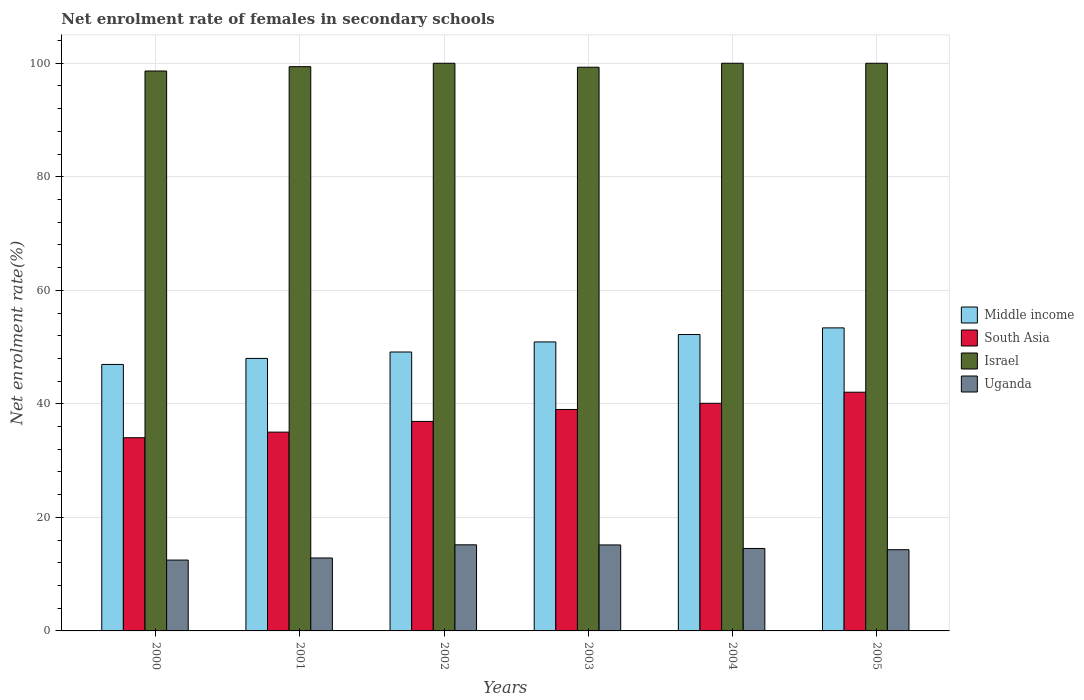Are the number of bars per tick equal to the number of legend labels?
Keep it short and to the point. Yes. Are the number of bars on each tick of the X-axis equal?
Provide a succinct answer. Yes. What is the label of the 1st group of bars from the left?
Provide a short and direct response. 2000. In how many cases, is the number of bars for a given year not equal to the number of legend labels?
Keep it short and to the point. 0. What is the net enrolment rate of females in secondary schools in Uganda in 2002?
Give a very brief answer. 15.17. Across all years, what is the maximum net enrolment rate of females in secondary schools in Uganda?
Offer a very short reply. 15.17. Across all years, what is the minimum net enrolment rate of females in secondary schools in Uganda?
Your response must be concise. 12.48. In which year was the net enrolment rate of females in secondary schools in Middle income maximum?
Your response must be concise. 2005. What is the total net enrolment rate of females in secondary schools in Uganda in the graph?
Your answer should be compact. 84.48. What is the difference between the net enrolment rate of females in secondary schools in Israel in 2002 and that in 2003?
Provide a succinct answer. 0.7. What is the difference between the net enrolment rate of females in secondary schools in Uganda in 2005 and the net enrolment rate of females in secondary schools in South Asia in 2004?
Ensure brevity in your answer.  -25.79. What is the average net enrolment rate of females in secondary schools in Uganda per year?
Provide a succinct answer. 14.08. In the year 2005, what is the difference between the net enrolment rate of females in secondary schools in Uganda and net enrolment rate of females in secondary schools in South Asia?
Ensure brevity in your answer.  -27.74. In how many years, is the net enrolment rate of females in secondary schools in Middle income greater than 16 %?
Make the answer very short. 6. What is the ratio of the net enrolment rate of females in secondary schools in Israel in 2001 to that in 2004?
Offer a very short reply. 0.99. What is the difference between the highest and the second highest net enrolment rate of females in secondary schools in Middle income?
Make the answer very short. 1.17. What is the difference between the highest and the lowest net enrolment rate of females in secondary schools in Uganda?
Give a very brief answer. 2.69. In how many years, is the net enrolment rate of females in secondary schools in Uganda greater than the average net enrolment rate of females in secondary schools in Uganda taken over all years?
Give a very brief answer. 4. Is the sum of the net enrolment rate of females in secondary schools in Uganda in 2000 and 2001 greater than the maximum net enrolment rate of females in secondary schools in Middle income across all years?
Ensure brevity in your answer.  No. Is it the case that in every year, the sum of the net enrolment rate of females in secondary schools in Uganda and net enrolment rate of females in secondary schools in South Asia is greater than the sum of net enrolment rate of females in secondary schools in Middle income and net enrolment rate of females in secondary schools in Israel?
Ensure brevity in your answer.  No. What does the 1st bar from the left in 2004 represents?
Provide a succinct answer. Middle income. How many bars are there?
Offer a terse response. 24. Are the values on the major ticks of Y-axis written in scientific E-notation?
Your answer should be very brief. No. Does the graph contain grids?
Keep it short and to the point. Yes. How many legend labels are there?
Ensure brevity in your answer.  4. What is the title of the graph?
Provide a succinct answer. Net enrolment rate of females in secondary schools. Does "Mali" appear as one of the legend labels in the graph?
Keep it short and to the point. No. What is the label or title of the X-axis?
Make the answer very short. Years. What is the label or title of the Y-axis?
Your response must be concise. Net enrolment rate(%). What is the Net enrolment rate(%) in Middle income in 2000?
Offer a very short reply. 46.94. What is the Net enrolment rate(%) of South Asia in 2000?
Give a very brief answer. 34.03. What is the Net enrolment rate(%) of Israel in 2000?
Provide a succinct answer. 98.64. What is the Net enrolment rate(%) in Uganda in 2000?
Provide a succinct answer. 12.48. What is the Net enrolment rate(%) of Middle income in 2001?
Ensure brevity in your answer.  48. What is the Net enrolment rate(%) in South Asia in 2001?
Give a very brief answer. 35.02. What is the Net enrolment rate(%) of Israel in 2001?
Ensure brevity in your answer.  99.4. What is the Net enrolment rate(%) in Uganda in 2001?
Your response must be concise. 12.85. What is the Net enrolment rate(%) in Middle income in 2002?
Ensure brevity in your answer.  49.13. What is the Net enrolment rate(%) in South Asia in 2002?
Offer a terse response. 36.91. What is the Net enrolment rate(%) of Israel in 2002?
Your answer should be very brief. 100. What is the Net enrolment rate(%) of Uganda in 2002?
Give a very brief answer. 15.17. What is the Net enrolment rate(%) of Middle income in 2003?
Your answer should be very brief. 50.91. What is the Net enrolment rate(%) in South Asia in 2003?
Ensure brevity in your answer.  39.01. What is the Net enrolment rate(%) of Israel in 2003?
Offer a terse response. 99.3. What is the Net enrolment rate(%) in Uganda in 2003?
Provide a succinct answer. 15.15. What is the Net enrolment rate(%) in Middle income in 2004?
Give a very brief answer. 52.21. What is the Net enrolment rate(%) in South Asia in 2004?
Provide a short and direct response. 40.1. What is the Net enrolment rate(%) in Israel in 2004?
Your answer should be very brief. 100. What is the Net enrolment rate(%) in Uganda in 2004?
Offer a terse response. 14.53. What is the Net enrolment rate(%) in Middle income in 2005?
Ensure brevity in your answer.  53.38. What is the Net enrolment rate(%) of South Asia in 2005?
Provide a succinct answer. 42.05. What is the Net enrolment rate(%) of Israel in 2005?
Provide a short and direct response. 100. What is the Net enrolment rate(%) of Uganda in 2005?
Your answer should be very brief. 14.31. Across all years, what is the maximum Net enrolment rate(%) in Middle income?
Your answer should be very brief. 53.38. Across all years, what is the maximum Net enrolment rate(%) in South Asia?
Your answer should be very brief. 42.05. Across all years, what is the maximum Net enrolment rate(%) of Uganda?
Your answer should be very brief. 15.17. Across all years, what is the minimum Net enrolment rate(%) in Middle income?
Keep it short and to the point. 46.94. Across all years, what is the minimum Net enrolment rate(%) in South Asia?
Make the answer very short. 34.03. Across all years, what is the minimum Net enrolment rate(%) of Israel?
Your answer should be very brief. 98.64. Across all years, what is the minimum Net enrolment rate(%) in Uganda?
Offer a terse response. 12.48. What is the total Net enrolment rate(%) of Middle income in the graph?
Provide a short and direct response. 300.59. What is the total Net enrolment rate(%) of South Asia in the graph?
Provide a short and direct response. 227.12. What is the total Net enrolment rate(%) in Israel in the graph?
Give a very brief answer. 597.34. What is the total Net enrolment rate(%) of Uganda in the graph?
Your response must be concise. 84.48. What is the difference between the Net enrolment rate(%) of Middle income in 2000 and that in 2001?
Make the answer very short. -1.06. What is the difference between the Net enrolment rate(%) of South Asia in 2000 and that in 2001?
Provide a succinct answer. -0.99. What is the difference between the Net enrolment rate(%) in Israel in 2000 and that in 2001?
Your answer should be very brief. -0.76. What is the difference between the Net enrolment rate(%) in Uganda in 2000 and that in 2001?
Provide a short and direct response. -0.37. What is the difference between the Net enrolment rate(%) of Middle income in 2000 and that in 2002?
Offer a terse response. -2.19. What is the difference between the Net enrolment rate(%) in South Asia in 2000 and that in 2002?
Make the answer very short. -2.88. What is the difference between the Net enrolment rate(%) of Israel in 2000 and that in 2002?
Your response must be concise. -1.36. What is the difference between the Net enrolment rate(%) of Uganda in 2000 and that in 2002?
Give a very brief answer. -2.69. What is the difference between the Net enrolment rate(%) in Middle income in 2000 and that in 2003?
Offer a very short reply. -3.96. What is the difference between the Net enrolment rate(%) in South Asia in 2000 and that in 2003?
Ensure brevity in your answer.  -4.98. What is the difference between the Net enrolment rate(%) in Israel in 2000 and that in 2003?
Make the answer very short. -0.66. What is the difference between the Net enrolment rate(%) in Uganda in 2000 and that in 2003?
Your answer should be very brief. -2.67. What is the difference between the Net enrolment rate(%) of Middle income in 2000 and that in 2004?
Give a very brief answer. -5.27. What is the difference between the Net enrolment rate(%) in South Asia in 2000 and that in 2004?
Your answer should be compact. -6.07. What is the difference between the Net enrolment rate(%) in Israel in 2000 and that in 2004?
Provide a short and direct response. -1.36. What is the difference between the Net enrolment rate(%) of Uganda in 2000 and that in 2004?
Give a very brief answer. -2.05. What is the difference between the Net enrolment rate(%) in Middle income in 2000 and that in 2005?
Keep it short and to the point. -6.44. What is the difference between the Net enrolment rate(%) of South Asia in 2000 and that in 2005?
Your answer should be very brief. -8.02. What is the difference between the Net enrolment rate(%) in Israel in 2000 and that in 2005?
Your response must be concise. -1.36. What is the difference between the Net enrolment rate(%) of Uganda in 2000 and that in 2005?
Provide a succinct answer. -1.83. What is the difference between the Net enrolment rate(%) of Middle income in 2001 and that in 2002?
Offer a very short reply. -1.13. What is the difference between the Net enrolment rate(%) of South Asia in 2001 and that in 2002?
Your answer should be very brief. -1.89. What is the difference between the Net enrolment rate(%) in Israel in 2001 and that in 2002?
Keep it short and to the point. -0.6. What is the difference between the Net enrolment rate(%) of Uganda in 2001 and that in 2002?
Offer a very short reply. -2.32. What is the difference between the Net enrolment rate(%) of Middle income in 2001 and that in 2003?
Ensure brevity in your answer.  -2.9. What is the difference between the Net enrolment rate(%) in South Asia in 2001 and that in 2003?
Your answer should be compact. -3.99. What is the difference between the Net enrolment rate(%) in Israel in 2001 and that in 2003?
Provide a succinct answer. 0.1. What is the difference between the Net enrolment rate(%) in Uganda in 2001 and that in 2003?
Offer a terse response. -2.3. What is the difference between the Net enrolment rate(%) of Middle income in 2001 and that in 2004?
Provide a short and direct response. -4.21. What is the difference between the Net enrolment rate(%) in South Asia in 2001 and that in 2004?
Offer a terse response. -5.08. What is the difference between the Net enrolment rate(%) of Israel in 2001 and that in 2004?
Give a very brief answer. -0.6. What is the difference between the Net enrolment rate(%) of Uganda in 2001 and that in 2004?
Provide a short and direct response. -1.68. What is the difference between the Net enrolment rate(%) of Middle income in 2001 and that in 2005?
Your response must be concise. -5.38. What is the difference between the Net enrolment rate(%) of South Asia in 2001 and that in 2005?
Provide a succinct answer. -7.03. What is the difference between the Net enrolment rate(%) in Israel in 2001 and that in 2005?
Make the answer very short. -0.6. What is the difference between the Net enrolment rate(%) of Uganda in 2001 and that in 2005?
Ensure brevity in your answer.  -1.46. What is the difference between the Net enrolment rate(%) in Middle income in 2002 and that in 2003?
Provide a short and direct response. -1.77. What is the difference between the Net enrolment rate(%) in South Asia in 2002 and that in 2003?
Provide a short and direct response. -2.1. What is the difference between the Net enrolment rate(%) in Israel in 2002 and that in 2003?
Your answer should be very brief. 0.7. What is the difference between the Net enrolment rate(%) in Uganda in 2002 and that in 2003?
Offer a very short reply. 0.02. What is the difference between the Net enrolment rate(%) of Middle income in 2002 and that in 2004?
Keep it short and to the point. -3.08. What is the difference between the Net enrolment rate(%) of South Asia in 2002 and that in 2004?
Give a very brief answer. -3.19. What is the difference between the Net enrolment rate(%) in Israel in 2002 and that in 2004?
Provide a succinct answer. 0. What is the difference between the Net enrolment rate(%) of Uganda in 2002 and that in 2004?
Make the answer very short. 0.64. What is the difference between the Net enrolment rate(%) in Middle income in 2002 and that in 2005?
Provide a succinct answer. -4.25. What is the difference between the Net enrolment rate(%) of South Asia in 2002 and that in 2005?
Offer a terse response. -5.14. What is the difference between the Net enrolment rate(%) in Uganda in 2002 and that in 2005?
Ensure brevity in your answer.  0.86. What is the difference between the Net enrolment rate(%) of Middle income in 2003 and that in 2004?
Offer a terse response. -1.3. What is the difference between the Net enrolment rate(%) in South Asia in 2003 and that in 2004?
Make the answer very short. -1.09. What is the difference between the Net enrolment rate(%) in Israel in 2003 and that in 2004?
Keep it short and to the point. -0.7. What is the difference between the Net enrolment rate(%) of Uganda in 2003 and that in 2004?
Provide a short and direct response. 0.62. What is the difference between the Net enrolment rate(%) of Middle income in 2003 and that in 2005?
Offer a very short reply. -2.48. What is the difference between the Net enrolment rate(%) in South Asia in 2003 and that in 2005?
Ensure brevity in your answer.  -3.04. What is the difference between the Net enrolment rate(%) of Israel in 2003 and that in 2005?
Provide a succinct answer. -0.7. What is the difference between the Net enrolment rate(%) in Uganda in 2003 and that in 2005?
Your answer should be very brief. 0.84. What is the difference between the Net enrolment rate(%) of Middle income in 2004 and that in 2005?
Make the answer very short. -1.17. What is the difference between the Net enrolment rate(%) in South Asia in 2004 and that in 2005?
Ensure brevity in your answer.  -1.95. What is the difference between the Net enrolment rate(%) of Israel in 2004 and that in 2005?
Give a very brief answer. 0. What is the difference between the Net enrolment rate(%) of Uganda in 2004 and that in 2005?
Your response must be concise. 0.22. What is the difference between the Net enrolment rate(%) in Middle income in 2000 and the Net enrolment rate(%) in South Asia in 2001?
Ensure brevity in your answer.  11.92. What is the difference between the Net enrolment rate(%) in Middle income in 2000 and the Net enrolment rate(%) in Israel in 2001?
Your answer should be very brief. -52.45. What is the difference between the Net enrolment rate(%) of Middle income in 2000 and the Net enrolment rate(%) of Uganda in 2001?
Offer a terse response. 34.09. What is the difference between the Net enrolment rate(%) in South Asia in 2000 and the Net enrolment rate(%) in Israel in 2001?
Provide a succinct answer. -65.37. What is the difference between the Net enrolment rate(%) in South Asia in 2000 and the Net enrolment rate(%) in Uganda in 2001?
Offer a terse response. 21.18. What is the difference between the Net enrolment rate(%) in Israel in 2000 and the Net enrolment rate(%) in Uganda in 2001?
Make the answer very short. 85.79. What is the difference between the Net enrolment rate(%) in Middle income in 2000 and the Net enrolment rate(%) in South Asia in 2002?
Offer a terse response. 10.04. What is the difference between the Net enrolment rate(%) of Middle income in 2000 and the Net enrolment rate(%) of Israel in 2002?
Provide a short and direct response. -53.06. What is the difference between the Net enrolment rate(%) of Middle income in 2000 and the Net enrolment rate(%) of Uganda in 2002?
Ensure brevity in your answer.  31.78. What is the difference between the Net enrolment rate(%) of South Asia in 2000 and the Net enrolment rate(%) of Israel in 2002?
Your answer should be compact. -65.97. What is the difference between the Net enrolment rate(%) in South Asia in 2000 and the Net enrolment rate(%) in Uganda in 2002?
Your response must be concise. 18.87. What is the difference between the Net enrolment rate(%) of Israel in 2000 and the Net enrolment rate(%) of Uganda in 2002?
Your answer should be compact. 83.47. What is the difference between the Net enrolment rate(%) in Middle income in 2000 and the Net enrolment rate(%) in South Asia in 2003?
Provide a short and direct response. 7.93. What is the difference between the Net enrolment rate(%) of Middle income in 2000 and the Net enrolment rate(%) of Israel in 2003?
Ensure brevity in your answer.  -52.36. What is the difference between the Net enrolment rate(%) in Middle income in 2000 and the Net enrolment rate(%) in Uganda in 2003?
Your answer should be very brief. 31.8. What is the difference between the Net enrolment rate(%) in South Asia in 2000 and the Net enrolment rate(%) in Israel in 2003?
Give a very brief answer. -65.27. What is the difference between the Net enrolment rate(%) of South Asia in 2000 and the Net enrolment rate(%) of Uganda in 2003?
Offer a very short reply. 18.89. What is the difference between the Net enrolment rate(%) in Israel in 2000 and the Net enrolment rate(%) in Uganda in 2003?
Provide a succinct answer. 83.49. What is the difference between the Net enrolment rate(%) in Middle income in 2000 and the Net enrolment rate(%) in South Asia in 2004?
Ensure brevity in your answer.  6.85. What is the difference between the Net enrolment rate(%) of Middle income in 2000 and the Net enrolment rate(%) of Israel in 2004?
Offer a very short reply. -53.06. What is the difference between the Net enrolment rate(%) in Middle income in 2000 and the Net enrolment rate(%) in Uganda in 2004?
Your answer should be compact. 32.42. What is the difference between the Net enrolment rate(%) of South Asia in 2000 and the Net enrolment rate(%) of Israel in 2004?
Provide a short and direct response. -65.97. What is the difference between the Net enrolment rate(%) in South Asia in 2000 and the Net enrolment rate(%) in Uganda in 2004?
Your response must be concise. 19.51. What is the difference between the Net enrolment rate(%) in Israel in 2000 and the Net enrolment rate(%) in Uganda in 2004?
Give a very brief answer. 84.11. What is the difference between the Net enrolment rate(%) of Middle income in 2000 and the Net enrolment rate(%) of South Asia in 2005?
Ensure brevity in your answer.  4.89. What is the difference between the Net enrolment rate(%) of Middle income in 2000 and the Net enrolment rate(%) of Israel in 2005?
Offer a terse response. -53.06. What is the difference between the Net enrolment rate(%) of Middle income in 2000 and the Net enrolment rate(%) of Uganda in 2005?
Offer a very short reply. 32.64. What is the difference between the Net enrolment rate(%) in South Asia in 2000 and the Net enrolment rate(%) in Israel in 2005?
Provide a succinct answer. -65.97. What is the difference between the Net enrolment rate(%) in South Asia in 2000 and the Net enrolment rate(%) in Uganda in 2005?
Provide a short and direct response. 19.73. What is the difference between the Net enrolment rate(%) of Israel in 2000 and the Net enrolment rate(%) of Uganda in 2005?
Your response must be concise. 84.33. What is the difference between the Net enrolment rate(%) in Middle income in 2001 and the Net enrolment rate(%) in South Asia in 2002?
Keep it short and to the point. 11.1. What is the difference between the Net enrolment rate(%) of Middle income in 2001 and the Net enrolment rate(%) of Israel in 2002?
Keep it short and to the point. -52. What is the difference between the Net enrolment rate(%) in Middle income in 2001 and the Net enrolment rate(%) in Uganda in 2002?
Keep it short and to the point. 32.84. What is the difference between the Net enrolment rate(%) of South Asia in 2001 and the Net enrolment rate(%) of Israel in 2002?
Ensure brevity in your answer.  -64.98. What is the difference between the Net enrolment rate(%) in South Asia in 2001 and the Net enrolment rate(%) in Uganda in 2002?
Your response must be concise. 19.85. What is the difference between the Net enrolment rate(%) in Israel in 2001 and the Net enrolment rate(%) in Uganda in 2002?
Offer a very short reply. 84.23. What is the difference between the Net enrolment rate(%) in Middle income in 2001 and the Net enrolment rate(%) in South Asia in 2003?
Ensure brevity in your answer.  8.99. What is the difference between the Net enrolment rate(%) in Middle income in 2001 and the Net enrolment rate(%) in Israel in 2003?
Your answer should be very brief. -51.3. What is the difference between the Net enrolment rate(%) in Middle income in 2001 and the Net enrolment rate(%) in Uganda in 2003?
Your response must be concise. 32.86. What is the difference between the Net enrolment rate(%) in South Asia in 2001 and the Net enrolment rate(%) in Israel in 2003?
Provide a short and direct response. -64.28. What is the difference between the Net enrolment rate(%) in South Asia in 2001 and the Net enrolment rate(%) in Uganda in 2003?
Offer a very short reply. 19.87. What is the difference between the Net enrolment rate(%) in Israel in 2001 and the Net enrolment rate(%) in Uganda in 2003?
Make the answer very short. 84.25. What is the difference between the Net enrolment rate(%) of Middle income in 2001 and the Net enrolment rate(%) of South Asia in 2004?
Keep it short and to the point. 7.91. What is the difference between the Net enrolment rate(%) in Middle income in 2001 and the Net enrolment rate(%) in Israel in 2004?
Your response must be concise. -52. What is the difference between the Net enrolment rate(%) in Middle income in 2001 and the Net enrolment rate(%) in Uganda in 2004?
Offer a very short reply. 33.48. What is the difference between the Net enrolment rate(%) of South Asia in 2001 and the Net enrolment rate(%) of Israel in 2004?
Ensure brevity in your answer.  -64.98. What is the difference between the Net enrolment rate(%) in South Asia in 2001 and the Net enrolment rate(%) in Uganda in 2004?
Give a very brief answer. 20.49. What is the difference between the Net enrolment rate(%) in Israel in 2001 and the Net enrolment rate(%) in Uganda in 2004?
Your answer should be very brief. 84.87. What is the difference between the Net enrolment rate(%) of Middle income in 2001 and the Net enrolment rate(%) of South Asia in 2005?
Your answer should be compact. 5.95. What is the difference between the Net enrolment rate(%) of Middle income in 2001 and the Net enrolment rate(%) of Israel in 2005?
Keep it short and to the point. -52. What is the difference between the Net enrolment rate(%) of Middle income in 2001 and the Net enrolment rate(%) of Uganda in 2005?
Your answer should be compact. 33.7. What is the difference between the Net enrolment rate(%) of South Asia in 2001 and the Net enrolment rate(%) of Israel in 2005?
Your answer should be compact. -64.98. What is the difference between the Net enrolment rate(%) in South Asia in 2001 and the Net enrolment rate(%) in Uganda in 2005?
Your response must be concise. 20.71. What is the difference between the Net enrolment rate(%) in Israel in 2001 and the Net enrolment rate(%) in Uganda in 2005?
Your answer should be compact. 85.09. What is the difference between the Net enrolment rate(%) of Middle income in 2002 and the Net enrolment rate(%) of South Asia in 2003?
Give a very brief answer. 10.12. What is the difference between the Net enrolment rate(%) of Middle income in 2002 and the Net enrolment rate(%) of Israel in 2003?
Offer a very short reply. -50.17. What is the difference between the Net enrolment rate(%) in Middle income in 2002 and the Net enrolment rate(%) in Uganda in 2003?
Offer a terse response. 33.99. What is the difference between the Net enrolment rate(%) in South Asia in 2002 and the Net enrolment rate(%) in Israel in 2003?
Offer a very short reply. -62.39. What is the difference between the Net enrolment rate(%) of South Asia in 2002 and the Net enrolment rate(%) of Uganda in 2003?
Provide a short and direct response. 21.76. What is the difference between the Net enrolment rate(%) in Israel in 2002 and the Net enrolment rate(%) in Uganda in 2003?
Make the answer very short. 84.85. What is the difference between the Net enrolment rate(%) in Middle income in 2002 and the Net enrolment rate(%) in South Asia in 2004?
Provide a short and direct response. 9.03. What is the difference between the Net enrolment rate(%) of Middle income in 2002 and the Net enrolment rate(%) of Israel in 2004?
Offer a terse response. -50.87. What is the difference between the Net enrolment rate(%) of Middle income in 2002 and the Net enrolment rate(%) of Uganda in 2004?
Your response must be concise. 34.61. What is the difference between the Net enrolment rate(%) in South Asia in 2002 and the Net enrolment rate(%) in Israel in 2004?
Give a very brief answer. -63.09. What is the difference between the Net enrolment rate(%) in South Asia in 2002 and the Net enrolment rate(%) in Uganda in 2004?
Your answer should be compact. 22.38. What is the difference between the Net enrolment rate(%) of Israel in 2002 and the Net enrolment rate(%) of Uganda in 2004?
Your answer should be very brief. 85.47. What is the difference between the Net enrolment rate(%) in Middle income in 2002 and the Net enrolment rate(%) in South Asia in 2005?
Give a very brief answer. 7.08. What is the difference between the Net enrolment rate(%) in Middle income in 2002 and the Net enrolment rate(%) in Israel in 2005?
Provide a succinct answer. -50.87. What is the difference between the Net enrolment rate(%) of Middle income in 2002 and the Net enrolment rate(%) of Uganda in 2005?
Your answer should be compact. 34.83. What is the difference between the Net enrolment rate(%) of South Asia in 2002 and the Net enrolment rate(%) of Israel in 2005?
Your response must be concise. -63.09. What is the difference between the Net enrolment rate(%) in South Asia in 2002 and the Net enrolment rate(%) in Uganda in 2005?
Your response must be concise. 22.6. What is the difference between the Net enrolment rate(%) in Israel in 2002 and the Net enrolment rate(%) in Uganda in 2005?
Your answer should be compact. 85.69. What is the difference between the Net enrolment rate(%) in Middle income in 2003 and the Net enrolment rate(%) in South Asia in 2004?
Your answer should be compact. 10.81. What is the difference between the Net enrolment rate(%) in Middle income in 2003 and the Net enrolment rate(%) in Israel in 2004?
Make the answer very short. -49.09. What is the difference between the Net enrolment rate(%) in Middle income in 2003 and the Net enrolment rate(%) in Uganda in 2004?
Your answer should be compact. 36.38. What is the difference between the Net enrolment rate(%) in South Asia in 2003 and the Net enrolment rate(%) in Israel in 2004?
Give a very brief answer. -60.99. What is the difference between the Net enrolment rate(%) of South Asia in 2003 and the Net enrolment rate(%) of Uganda in 2004?
Offer a very short reply. 24.48. What is the difference between the Net enrolment rate(%) in Israel in 2003 and the Net enrolment rate(%) in Uganda in 2004?
Provide a short and direct response. 84.78. What is the difference between the Net enrolment rate(%) of Middle income in 2003 and the Net enrolment rate(%) of South Asia in 2005?
Give a very brief answer. 8.86. What is the difference between the Net enrolment rate(%) in Middle income in 2003 and the Net enrolment rate(%) in Israel in 2005?
Keep it short and to the point. -49.09. What is the difference between the Net enrolment rate(%) in Middle income in 2003 and the Net enrolment rate(%) in Uganda in 2005?
Make the answer very short. 36.6. What is the difference between the Net enrolment rate(%) of South Asia in 2003 and the Net enrolment rate(%) of Israel in 2005?
Your answer should be compact. -60.99. What is the difference between the Net enrolment rate(%) in South Asia in 2003 and the Net enrolment rate(%) in Uganda in 2005?
Offer a very short reply. 24.7. What is the difference between the Net enrolment rate(%) in Israel in 2003 and the Net enrolment rate(%) in Uganda in 2005?
Ensure brevity in your answer.  84.99. What is the difference between the Net enrolment rate(%) of Middle income in 2004 and the Net enrolment rate(%) of South Asia in 2005?
Offer a terse response. 10.16. What is the difference between the Net enrolment rate(%) in Middle income in 2004 and the Net enrolment rate(%) in Israel in 2005?
Offer a terse response. -47.79. What is the difference between the Net enrolment rate(%) in Middle income in 2004 and the Net enrolment rate(%) in Uganda in 2005?
Provide a succinct answer. 37.91. What is the difference between the Net enrolment rate(%) in South Asia in 2004 and the Net enrolment rate(%) in Israel in 2005?
Provide a short and direct response. -59.9. What is the difference between the Net enrolment rate(%) of South Asia in 2004 and the Net enrolment rate(%) of Uganda in 2005?
Your response must be concise. 25.79. What is the difference between the Net enrolment rate(%) of Israel in 2004 and the Net enrolment rate(%) of Uganda in 2005?
Offer a very short reply. 85.69. What is the average Net enrolment rate(%) of Middle income per year?
Your answer should be very brief. 50.1. What is the average Net enrolment rate(%) in South Asia per year?
Give a very brief answer. 37.85. What is the average Net enrolment rate(%) of Israel per year?
Provide a succinct answer. 99.56. What is the average Net enrolment rate(%) of Uganda per year?
Your answer should be compact. 14.08. In the year 2000, what is the difference between the Net enrolment rate(%) in Middle income and Net enrolment rate(%) in South Asia?
Offer a very short reply. 12.91. In the year 2000, what is the difference between the Net enrolment rate(%) in Middle income and Net enrolment rate(%) in Israel?
Your answer should be very brief. -51.69. In the year 2000, what is the difference between the Net enrolment rate(%) in Middle income and Net enrolment rate(%) in Uganda?
Make the answer very short. 34.46. In the year 2000, what is the difference between the Net enrolment rate(%) of South Asia and Net enrolment rate(%) of Israel?
Ensure brevity in your answer.  -64.6. In the year 2000, what is the difference between the Net enrolment rate(%) in South Asia and Net enrolment rate(%) in Uganda?
Your response must be concise. 21.55. In the year 2000, what is the difference between the Net enrolment rate(%) of Israel and Net enrolment rate(%) of Uganda?
Ensure brevity in your answer.  86.16. In the year 2001, what is the difference between the Net enrolment rate(%) in Middle income and Net enrolment rate(%) in South Asia?
Offer a very short reply. 12.98. In the year 2001, what is the difference between the Net enrolment rate(%) of Middle income and Net enrolment rate(%) of Israel?
Provide a short and direct response. -51.39. In the year 2001, what is the difference between the Net enrolment rate(%) of Middle income and Net enrolment rate(%) of Uganda?
Make the answer very short. 35.15. In the year 2001, what is the difference between the Net enrolment rate(%) of South Asia and Net enrolment rate(%) of Israel?
Ensure brevity in your answer.  -64.38. In the year 2001, what is the difference between the Net enrolment rate(%) of South Asia and Net enrolment rate(%) of Uganda?
Your answer should be compact. 22.17. In the year 2001, what is the difference between the Net enrolment rate(%) in Israel and Net enrolment rate(%) in Uganda?
Provide a succinct answer. 86.55. In the year 2002, what is the difference between the Net enrolment rate(%) in Middle income and Net enrolment rate(%) in South Asia?
Your answer should be very brief. 12.23. In the year 2002, what is the difference between the Net enrolment rate(%) of Middle income and Net enrolment rate(%) of Israel?
Make the answer very short. -50.87. In the year 2002, what is the difference between the Net enrolment rate(%) in Middle income and Net enrolment rate(%) in Uganda?
Ensure brevity in your answer.  33.97. In the year 2002, what is the difference between the Net enrolment rate(%) in South Asia and Net enrolment rate(%) in Israel?
Your answer should be compact. -63.09. In the year 2002, what is the difference between the Net enrolment rate(%) of South Asia and Net enrolment rate(%) of Uganda?
Your response must be concise. 21.74. In the year 2002, what is the difference between the Net enrolment rate(%) in Israel and Net enrolment rate(%) in Uganda?
Provide a short and direct response. 84.83. In the year 2003, what is the difference between the Net enrolment rate(%) in Middle income and Net enrolment rate(%) in South Asia?
Make the answer very short. 11.9. In the year 2003, what is the difference between the Net enrolment rate(%) of Middle income and Net enrolment rate(%) of Israel?
Your answer should be very brief. -48.39. In the year 2003, what is the difference between the Net enrolment rate(%) in Middle income and Net enrolment rate(%) in Uganda?
Give a very brief answer. 35.76. In the year 2003, what is the difference between the Net enrolment rate(%) of South Asia and Net enrolment rate(%) of Israel?
Provide a succinct answer. -60.29. In the year 2003, what is the difference between the Net enrolment rate(%) in South Asia and Net enrolment rate(%) in Uganda?
Provide a short and direct response. 23.86. In the year 2003, what is the difference between the Net enrolment rate(%) of Israel and Net enrolment rate(%) of Uganda?
Offer a very short reply. 84.15. In the year 2004, what is the difference between the Net enrolment rate(%) of Middle income and Net enrolment rate(%) of South Asia?
Your answer should be very brief. 12.11. In the year 2004, what is the difference between the Net enrolment rate(%) of Middle income and Net enrolment rate(%) of Israel?
Provide a short and direct response. -47.79. In the year 2004, what is the difference between the Net enrolment rate(%) of Middle income and Net enrolment rate(%) of Uganda?
Ensure brevity in your answer.  37.69. In the year 2004, what is the difference between the Net enrolment rate(%) of South Asia and Net enrolment rate(%) of Israel?
Give a very brief answer. -59.9. In the year 2004, what is the difference between the Net enrolment rate(%) in South Asia and Net enrolment rate(%) in Uganda?
Your answer should be compact. 25.57. In the year 2004, what is the difference between the Net enrolment rate(%) of Israel and Net enrolment rate(%) of Uganda?
Offer a very short reply. 85.47. In the year 2005, what is the difference between the Net enrolment rate(%) of Middle income and Net enrolment rate(%) of South Asia?
Keep it short and to the point. 11.33. In the year 2005, what is the difference between the Net enrolment rate(%) in Middle income and Net enrolment rate(%) in Israel?
Provide a succinct answer. -46.62. In the year 2005, what is the difference between the Net enrolment rate(%) in Middle income and Net enrolment rate(%) in Uganda?
Provide a short and direct response. 39.08. In the year 2005, what is the difference between the Net enrolment rate(%) in South Asia and Net enrolment rate(%) in Israel?
Provide a succinct answer. -57.95. In the year 2005, what is the difference between the Net enrolment rate(%) in South Asia and Net enrolment rate(%) in Uganda?
Your response must be concise. 27.74. In the year 2005, what is the difference between the Net enrolment rate(%) of Israel and Net enrolment rate(%) of Uganda?
Provide a short and direct response. 85.69. What is the ratio of the Net enrolment rate(%) of Middle income in 2000 to that in 2001?
Provide a short and direct response. 0.98. What is the ratio of the Net enrolment rate(%) of South Asia in 2000 to that in 2001?
Provide a short and direct response. 0.97. What is the ratio of the Net enrolment rate(%) in Uganda in 2000 to that in 2001?
Your response must be concise. 0.97. What is the ratio of the Net enrolment rate(%) of Middle income in 2000 to that in 2002?
Make the answer very short. 0.96. What is the ratio of the Net enrolment rate(%) in South Asia in 2000 to that in 2002?
Offer a very short reply. 0.92. What is the ratio of the Net enrolment rate(%) of Israel in 2000 to that in 2002?
Your answer should be compact. 0.99. What is the ratio of the Net enrolment rate(%) in Uganda in 2000 to that in 2002?
Offer a terse response. 0.82. What is the ratio of the Net enrolment rate(%) of Middle income in 2000 to that in 2003?
Your answer should be very brief. 0.92. What is the ratio of the Net enrolment rate(%) in South Asia in 2000 to that in 2003?
Give a very brief answer. 0.87. What is the ratio of the Net enrolment rate(%) of Israel in 2000 to that in 2003?
Provide a short and direct response. 0.99. What is the ratio of the Net enrolment rate(%) of Uganda in 2000 to that in 2003?
Your answer should be compact. 0.82. What is the ratio of the Net enrolment rate(%) in Middle income in 2000 to that in 2004?
Offer a terse response. 0.9. What is the ratio of the Net enrolment rate(%) of South Asia in 2000 to that in 2004?
Offer a very short reply. 0.85. What is the ratio of the Net enrolment rate(%) of Israel in 2000 to that in 2004?
Offer a terse response. 0.99. What is the ratio of the Net enrolment rate(%) in Uganda in 2000 to that in 2004?
Offer a very short reply. 0.86. What is the ratio of the Net enrolment rate(%) in Middle income in 2000 to that in 2005?
Provide a short and direct response. 0.88. What is the ratio of the Net enrolment rate(%) of South Asia in 2000 to that in 2005?
Your response must be concise. 0.81. What is the ratio of the Net enrolment rate(%) of Israel in 2000 to that in 2005?
Keep it short and to the point. 0.99. What is the ratio of the Net enrolment rate(%) of Uganda in 2000 to that in 2005?
Offer a very short reply. 0.87. What is the ratio of the Net enrolment rate(%) in Middle income in 2001 to that in 2002?
Ensure brevity in your answer.  0.98. What is the ratio of the Net enrolment rate(%) of South Asia in 2001 to that in 2002?
Offer a terse response. 0.95. What is the ratio of the Net enrolment rate(%) in Israel in 2001 to that in 2002?
Give a very brief answer. 0.99. What is the ratio of the Net enrolment rate(%) of Uganda in 2001 to that in 2002?
Your response must be concise. 0.85. What is the ratio of the Net enrolment rate(%) of Middle income in 2001 to that in 2003?
Your response must be concise. 0.94. What is the ratio of the Net enrolment rate(%) in South Asia in 2001 to that in 2003?
Offer a terse response. 0.9. What is the ratio of the Net enrolment rate(%) of Uganda in 2001 to that in 2003?
Your response must be concise. 0.85. What is the ratio of the Net enrolment rate(%) of Middle income in 2001 to that in 2004?
Offer a very short reply. 0.92. What is the ratio of the Net enrolment rate(%) of South Asia in 2001 to that in 2004?
Offer a very short reply. 0.87. What is the ratio of the Net enrolment rate(%) of Israel in 2001 to that in 2004?
Your answer should be compact. 0.99. What is the ratio of the Net enrolment rate(%) of Uganda in 2001 to that in 2004?
Make the answer very short. 0.88. What is the ratio of the Net enrolment rate(%) in Middle income in 2001 to that in 2005?
Your answer should be very brief. 0.9. What is the ratio of the Net enrolment rate(%) in South Asia in 2001 to that in 2005?
Make the answer very short. 0.83. What is the ratio of the Net enrolment rate(%) of Israel in 2001 to that in 2005?
Your answer should be very brief. 0.99. What is the ratio of the Net enrolment rate(%) of Uganda in 2001 to that in 2005?
Ensure brevity in your answer.  0.9. What is the ratio of the Net enrolment rate(%) in Middle income in 2002 to that in 2003?
Ensure brevity in your answer.  0.97. What is the ratio of the Net enrolment rate(%) in South Asia in 2002 to that in 2003?
Provide a short and direct response. 0.95. What is the ratio of the Net enrolment rate(%) in Israel in 2002 to that in 2003?
Provide a short and direct response. 1.01. What is the ratio of the Net enrolment rate(%) of Uganda in 2002 to that in 2003?
Your response must be concise. 1. What is the ratio of the Net enrolment rate(%) of Middle income in 2002 to that in 2004?
Make the answer very short. 0.94. What is the ratio of the Net enrolment rate(%) of South Asia in 2002 to that in 2004?
Ensure brevity in your answer.  0.92. What is the ratio of the Net enrolment rate(%) of Israel in 2002 to that in 2004?
Your answer should be very brief. 1. What is the ratio of the Net enrolment rate(%) in Uganda in 2002 to that in 2004?
Offer a very short reply. 1.04. What is the ratio of the Net enrolment rate(%) in Middle income in 2002 to that in 2005?
Your answer should be very brief. 0.92. What is the ratio of the Net enrolment rate(%) in South Asia in 2002 to that in 2005?
Keep it short and to the point. 0.88. What is the ratio of the Net enrolment rate(%) in Uganda in 2002 to that in 2005?
Give a very brief answer. 1.06. What is the ratio of the Net enrolment rate(%) in Middle income in 2003 to that in 2004?
Your answer should be very brief. 0.97. What is the ratio of the Net enrolment rate(%) in South Asia in 2003 to that in 2004?
Make the answer very short. 0.97. What is the ratio of the Net enrolment rate(%) in Uganda in 2003 to that in 2004?
Provide a short and direct response. 1.04. What is the ratio of the Net enrolment rate(%) in Middle income in 2003 to that in 2005?
Provide a short and direct response. 0.95. What is the ratio of the Net enrolment rate(%) of South Asia in 2003 to that in 2005?
Offer a very short reply. 0.93. What is the ratio of the Net enrolment rate(%) of Uganda in 2003 to that in 2005?
Offer a very short reply. 1.06. What is the ratio of the Net enrolment rate(%) of Middle income in 2004 to that in 2005?
Offer a terse response. 0.98. What is the ratio of the Net enrolment rate(%) in South Asia in 2004 to that in 2005?
Your answer should be compact. 0.95. What is the ratio of the Net enrolment rate(%) in Uganda in 2004 to that in 2005?
Your response must be concise. 1.02. What is the difference between the highest and the second highest Net enrolment rate(%) in Middle income?
Provide a short and direct response. 1.17. What is the difference between the highest and the second highest Net enrolment rate(%) in South Asia?
Make the answer very short. 1.95. What is the difference between the highest and the second highest Net enrolment rate(%) in Israel?
Your answer should be very brief. 0. What is the difference between the highest and the second highest Net enrolment rate(%) in Uganda?
Offer a terse response. 0.02. What is the difference between the highest and the lowest Net enrolment rate(%) in Middle income?
Provide a succinct answer. 6.44. What is the difference between the highest and the lowest Net enrolment rate(%) in South Asia?
Offer a terse response. 8.02. What is the difference between the highest and the lowest Net enrolment rate(%) in Israel?
Give a very brief answer. 1.36. What is the difference between the highest and the lowest Net enrolment rate(%) in Uganda?
Make the answer very short. 2.69. 